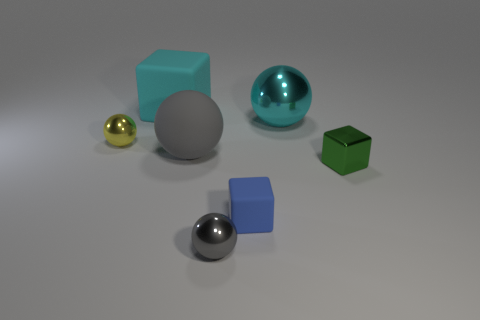What is the material of the small thing that is behind the tiny blue matte thing and on the left side of the big metal sphere?
Provide a succinct answer. Metal. Is the shape of the tiny thing in front of the blue block the same as the rubber object that is in front of the shiny block?
Provide a short and direct response. No. There is a thing that is the same color as the rubber sphere; what shape is it?
Keep it short and to the point. Sphere. What number of objects are either small blue blocks that are to the left of the green shiny thing or big cyan rubber cylinders?
Provide a short and direct response. 1. Is the cyan ball the same size as the matte ball?
Your response must be concise. Yes. What color is the metal object in front of the metal block?
Provide a short and direct response. Gray. There is a cyan thing that is made of the same material as the green block; what size is it?
Give a very brief answer. Large. There is a gray metal ball; is its size the same as the sphere to the left of the cyan block?
Give a very brief answer. Yes. There is a large ball on the right side of the tiny gray metal object; what is it made of?
Your response must be concise. Metal. There is a cyan sphere that is to the right of the cyan rubber object; how many gray matte objects are to the right of it?
Keep it short and to the point. 0. 